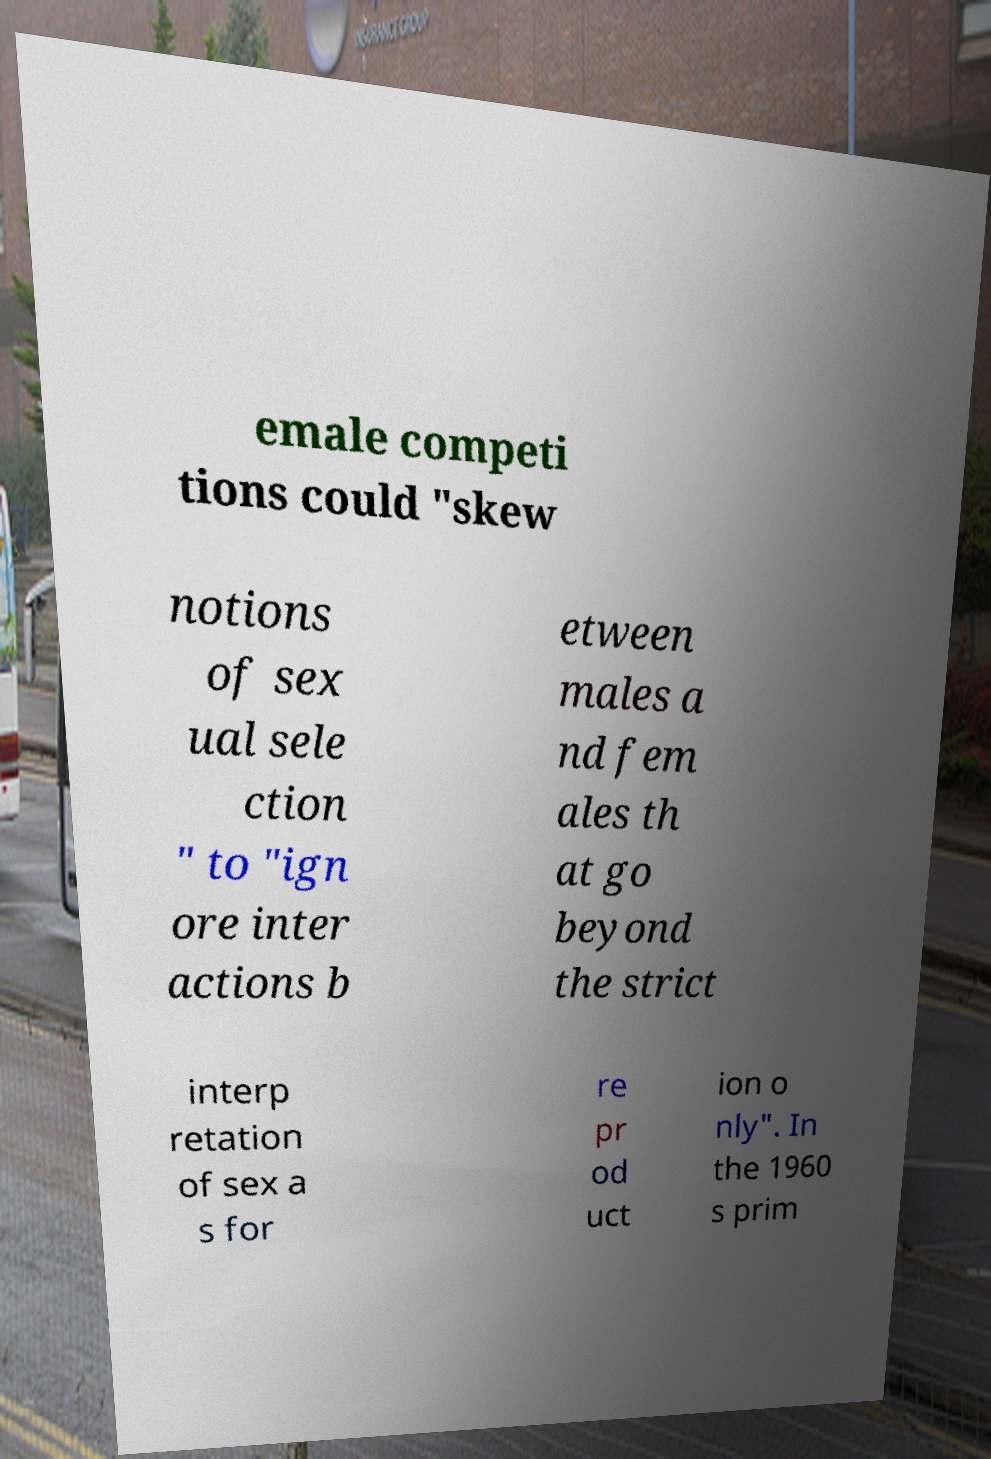Can you read and provide the text displayed in the image?This photo seems to have some interesting text. Can you extract and type it out for me? emale competi tions could "skew notions of sex ual sele ction " to "ign ore inter actions b etween males a nd fem ales th at go beyond the strict interp retation of sex a s for re pr od uct ion o nly". In the 1960 s prim 